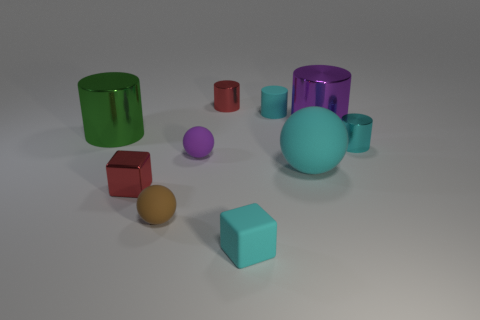Subtract all green cylinders. How many cylinders are left? 4 Subtract all rubber cylinders. How many cylinders are left? 4 Subtract all blue cylinders. Subtract all brown blocks. How many cylinders are left? 5 Subtract all spheres. How many objects are left? 7 Add 2 large red metal spheres. How many large red metal spheres exist? 2 Subtract 0 blue cylinders. How many objects are left? 10 Subtract all brown balls. Subtract all green shiny things. How many objects are left? 8 Add 9 large purple shiny cylinders. How many large purple shiny cylinders are left? 10 